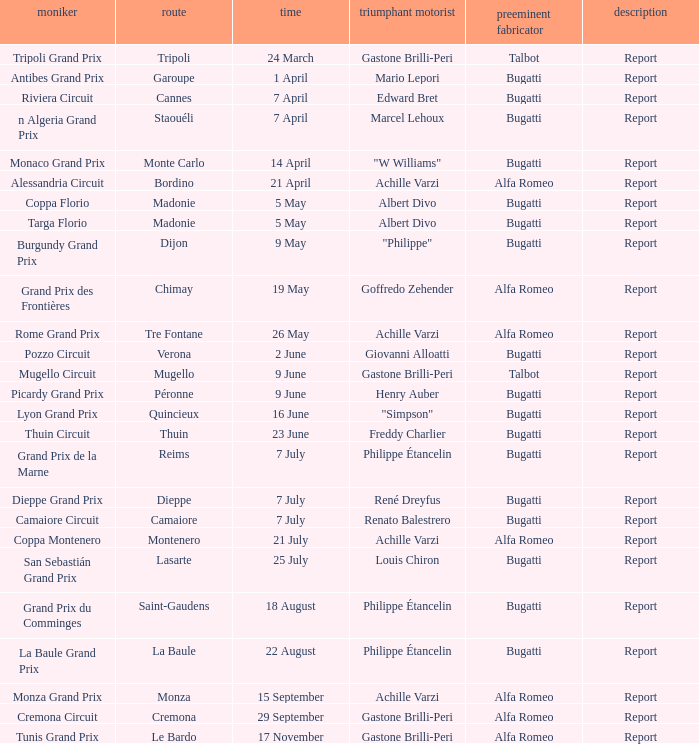What Date has a Name of thuin circuit? 23 June. 